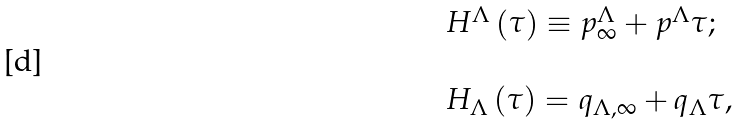<formula> <loc_0><loc_0><loc_500><loc_500>\begin{array} { l } H ^ { \Lambda } \left ( \tau \right ) \equiv p _ { \infty } ^ { \Lambda } + p ^ { \Lambda } \tau ; \\ \\ H _ { \Lambda } \left ( \tau \right ) = q _ { \Lambda , \infty } + q _ { \Lambda } \tau , \end{array}</formula> 